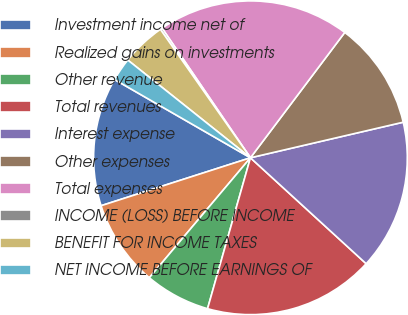Convert chart to OTSL. <chart><loc_0><loc_0><loc_500><loc_500><pie_chart><fcel>Investment income net of<fcel>Realized gains on investments<fcel>Other revenue<fcel>Total revenues<fcel>Interest expense<fcel>Other expenses<fcel>Total expenses<fcel>INCOME (LOSS) BEFORE INCOME<fcel>BENEFIT FOR INCOME TAXES<fcel>NET INCOME BEFORE EARNINGS OF<nl><fcel>13.26%<fcel>8.91%<fcel>6.74%<fcel>17.61%<fcel>15.44%<fcel>11.09%<fcel>19.79%<fcel>0.21%<fcel>4.56%<fcel>2.39%<nl></chart> 